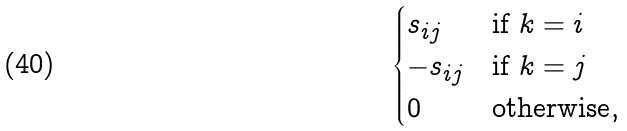<formula> <loc_0><loc_0><loc_500><loc_500>\begin{cases} s _ { i j } & \text {if $k=i$} \\ - s _ { i j } & \text {if $k=j$} \\ 0 & \text {otherwise} , \end{cases}</formula> 